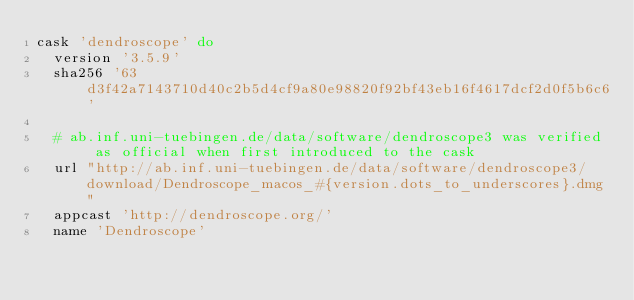Convert code to text. <code><loc_0><loc_0><loc_500><loc_500><_Ruby_>cask 'dendroscope' do
  version '3.5.9'
  sha256 '63d3f42a7143710d40c2b5d4cf9a80e98820f92bf43eb16f4617dcf2d0f5b6c6'

  # ab.inf.uni-tuebingen.de/data/software/dendroscope3 was verified as official when first introduced to the cask
  url "http://ab.inf.uni-tuebingen.de/data/software/dendroscope3/download/Dendroscope_macos_#{version.dots_to_underscores}.dmg"
  appcast 'http://dendroscope.org/'
  name 'Dendroscope'</code> 